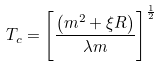Convert formula to latex. <formula><loc_0><loc_0><loc_500><loc_500>T _ { c } = \left [ \frac { \left ( m ^ { 2 } + \xi R \right ) } { \lambda m } \right ] ^ { \frac { 1 } { 2 } }</formula> 